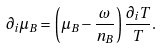<formula> <loc_0><loc_0><loc_500><loc_500>\partial _ { i } \mu _ { B } = \left ( \mu _ { B } - \frac { \omega } { n _ { B } } \right ) \frac { \partial _ { i } T } { T } .</formula> 